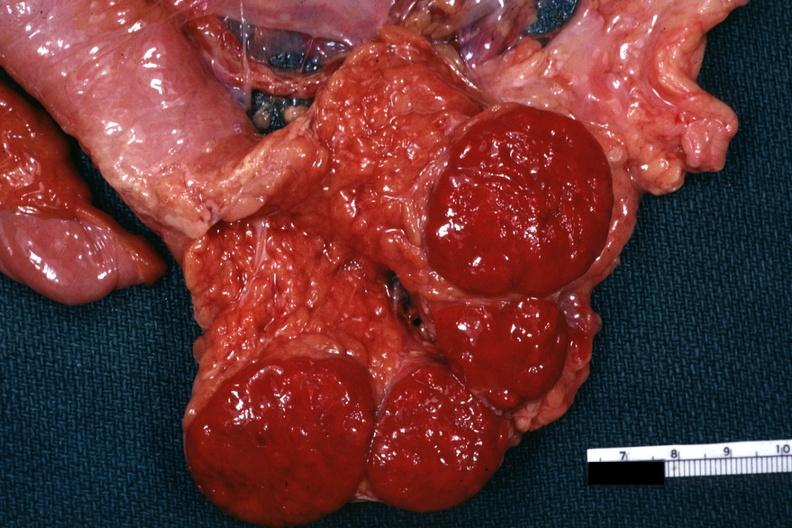what is present?
Answer the question using a single word or phrase. Hematologic 